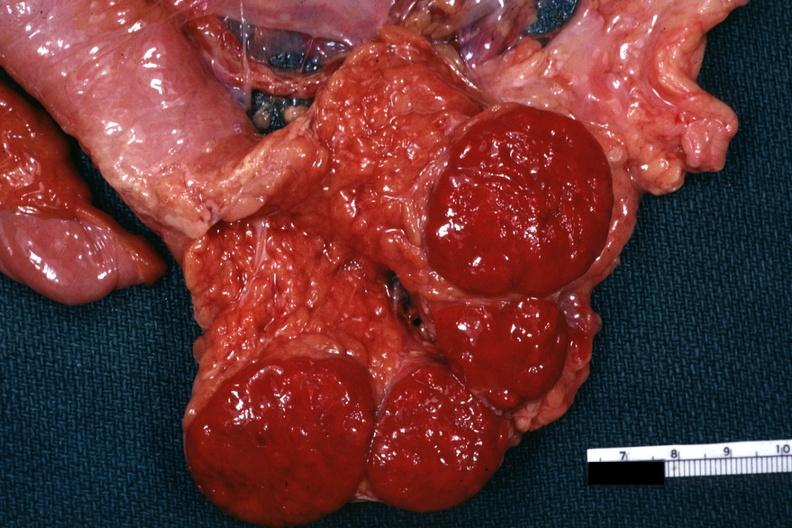what is present?
Answer the question using a single word or phrase. Hematologic 